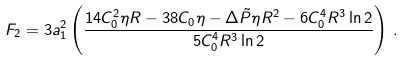<formula> <loc_0><loc_0><loc_500><loc_500>F _ { 2 } = 3 a _ { 1 } ^ { 2 } \left ( \frac { 1 4 C _ { 0 } ^ { 2 } \eta R - 3 8 C _ { 0 } \eta - \Delta \tilde { P } \eta R ^ { 2 } - 6 C _ { 0 } ^ { 4 } R ^ { 3 } \ln 2 } { 5 C _ { 0 } ^ { 4 } R ^ { 3 } \ln 2 } \right ) \, .</formula> 